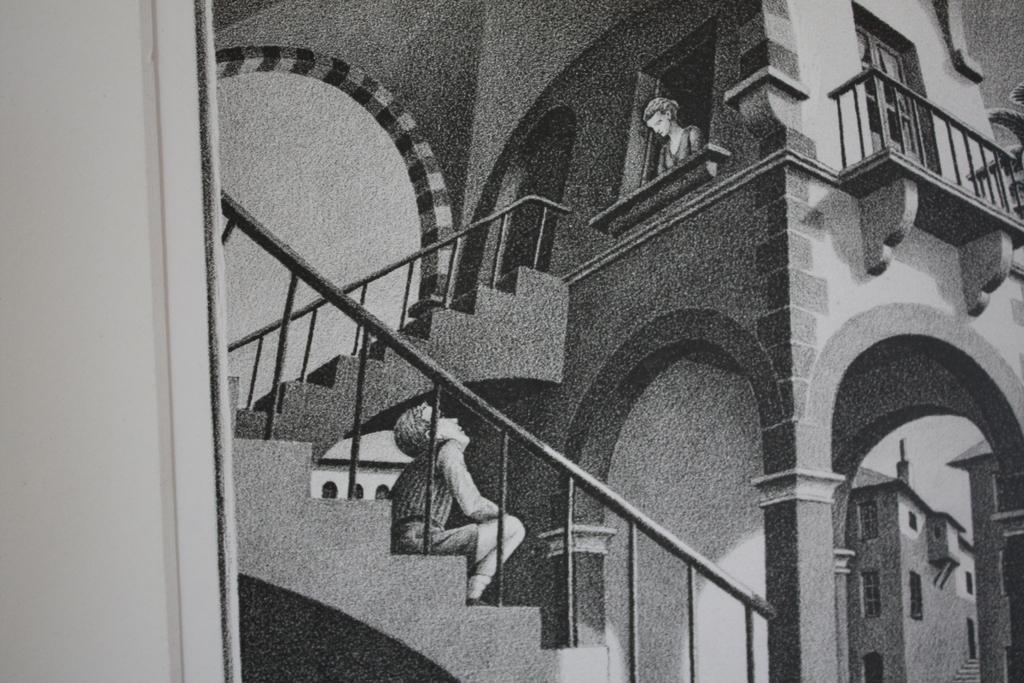Could you give a brief overview of what you see in this image? This is pencil drawing. There is a building. A person is sitting on the stairs which has railing. A person is standing near a window inside the building. At the back there is another building. 